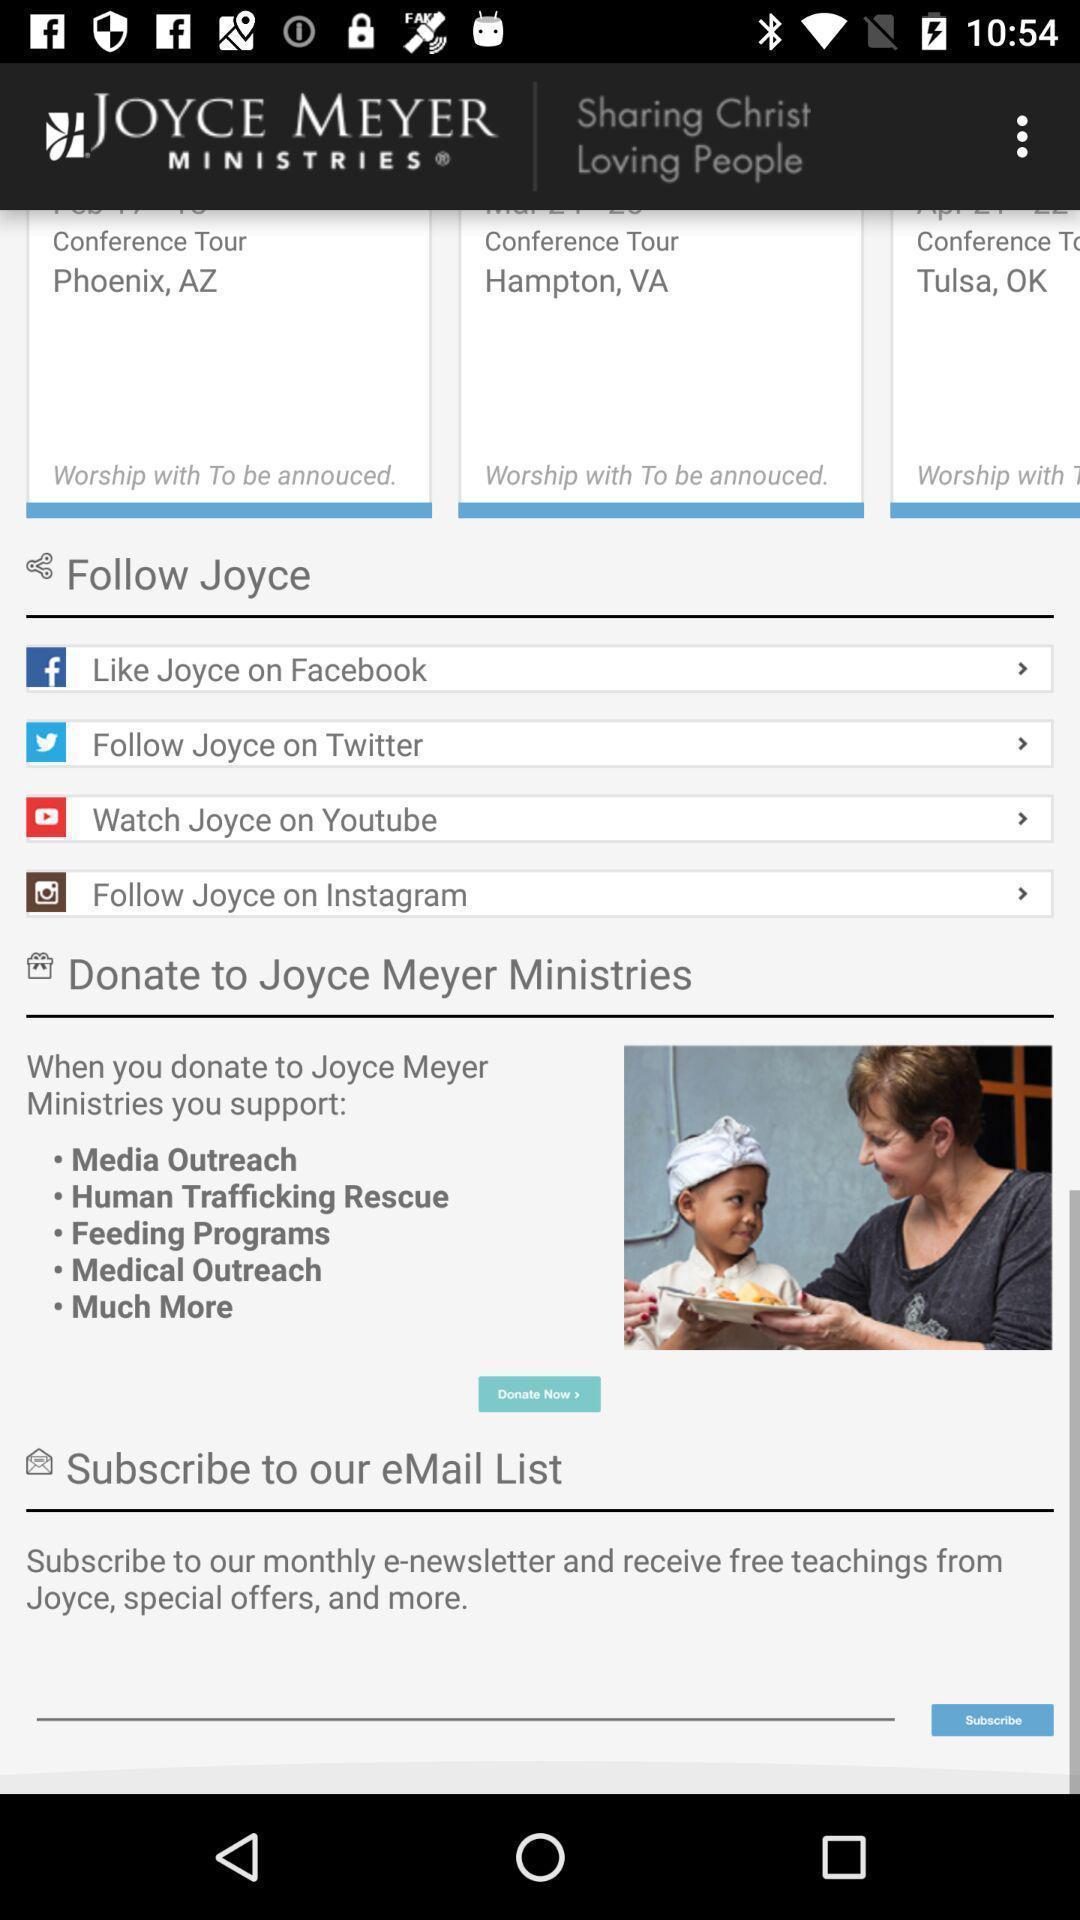Describe the content in this image. Sharing christ loving people in joyce meyer. 